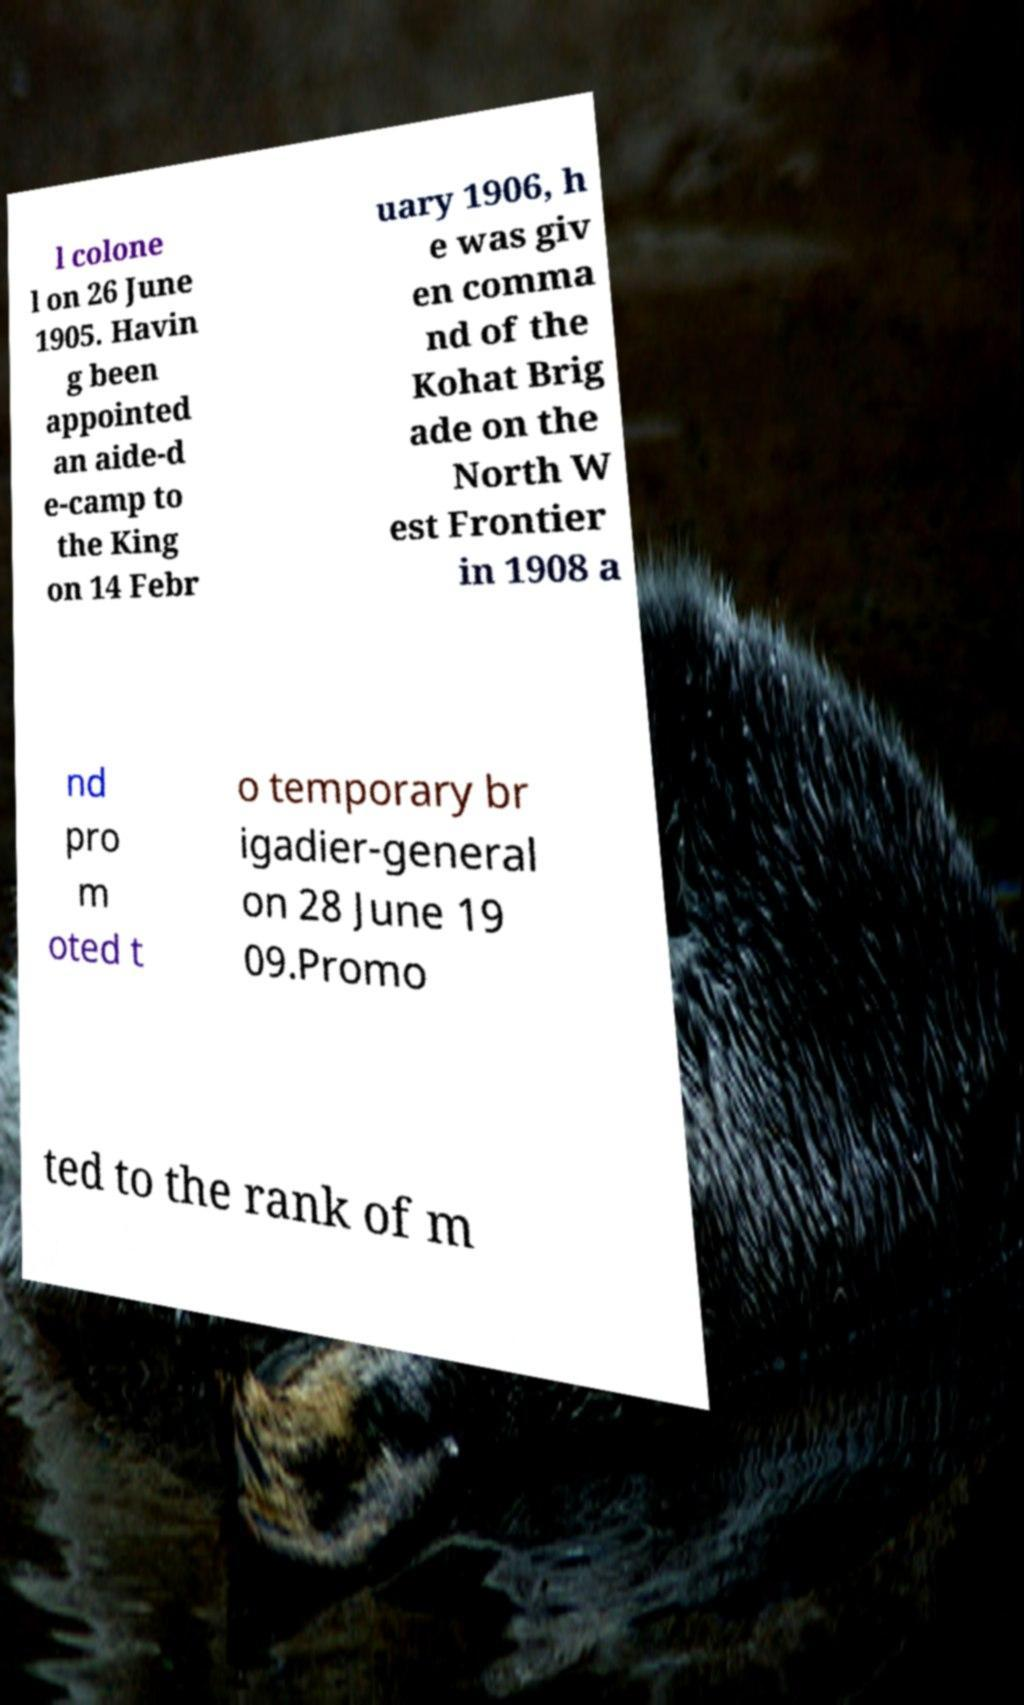Could you extract and type out the text from this image? l colone l on 26 June 1905. Havin g been appointed an aide-d e-camp to the King on 14 Febr uary 1906, h e was giv en comma nd of the Kohat Brig ade on the North W est Frontier in 1908 a nd pro m oted t o temporary br igadier-general on 28 June 19 09.Promo ted to the rank of m 